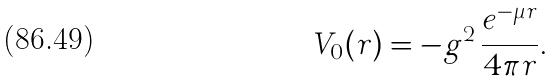<formula> <loc_0><loc_0><loc_500><loc_500>V _ { 0 } ( r ) = - g ^ { 2 } \, \frac { e ^ { - \mu r } } { 4 \pi r } .</formula> 